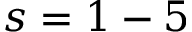Convert formula to latex. <formula><loc_0><loc_0><loc_500><loc_500>s = 1 - 5</formula> 